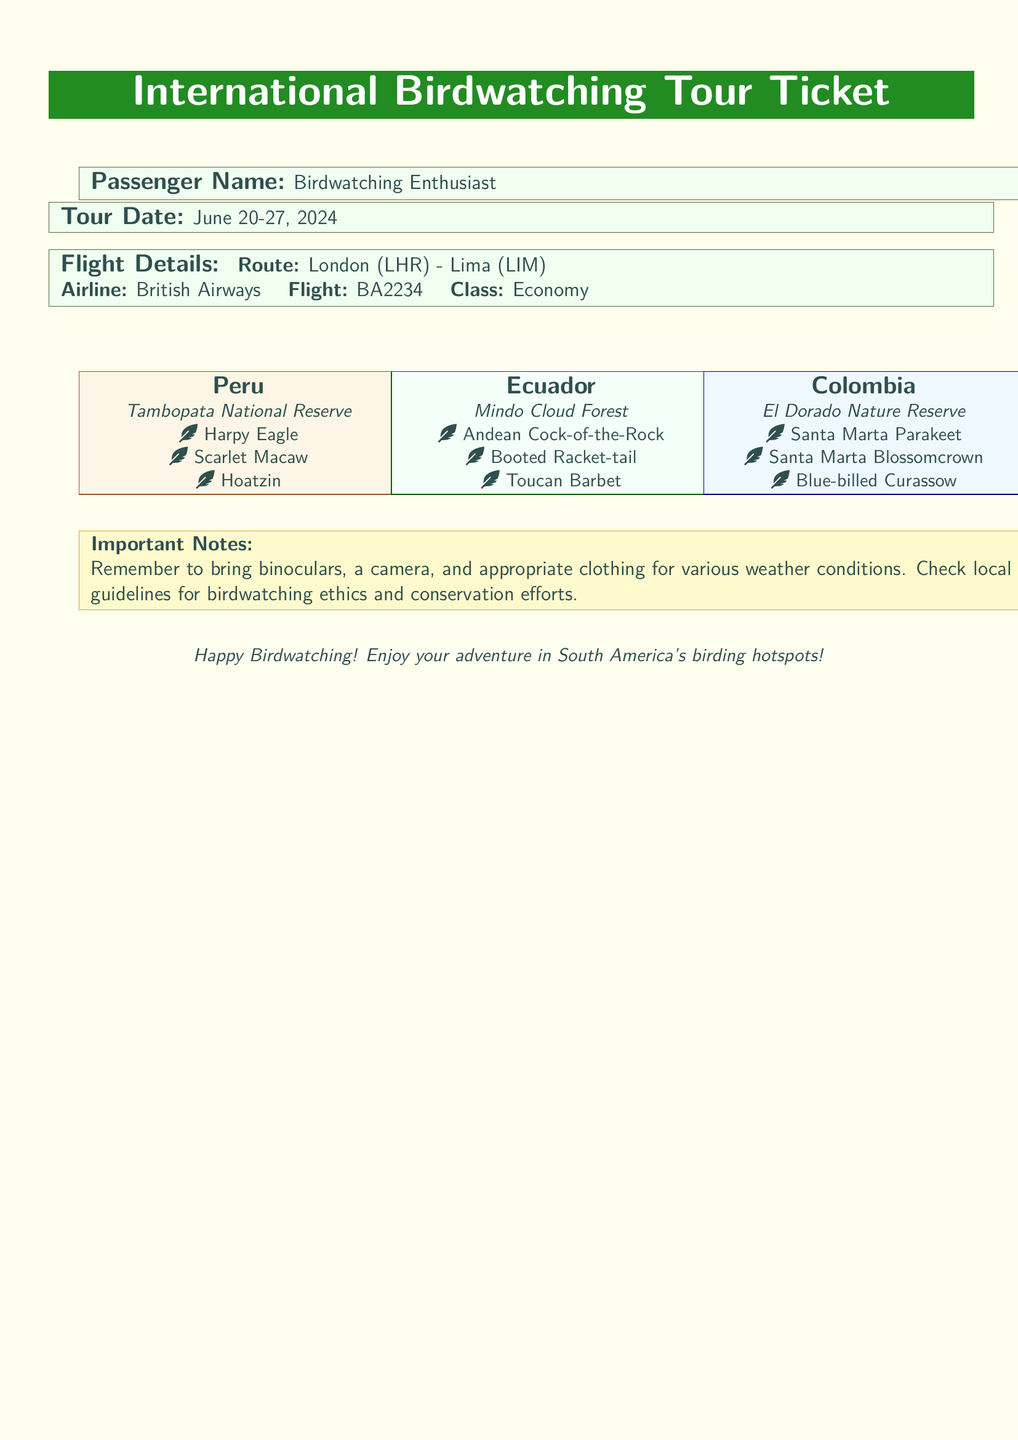What is the passenger name? The passenger name listed on the ticket is the first relevant detail presented in the document.
Answer: Birdwatching Enthusiast What are the tour dates? The tour dates are a crucial piece of information shown in a prominent section of the document.
Answer: June 20-27, 2024 What is the airline? The airline is mentioned in the flight details section, which provides specifics about the journey.
Answer: British Airways Which bird species can be observed in Peru? The document lists specific bird species that can be seen in each destination, focusing on Peru here.
Answer: Harpy Eagle, Scarlet Macaw, Hoatzin What is the location of the Mindo Cloud Forest? The location of the Mindo Cloud Forest is highlighted in the document, in combination with the expected bird species.
Answer: Ecuador What is one important note for travelers? Important notes for travelers are provided at the end of the document to ensure proper preparation for the tour.
Answer: Bring binoculars How many bird species are mentioned for Colombia? The document specifies the bird species expected to be observed in Colombia, which requires counting from the information given.
Answer: Three Which class is the ticket booked under? The class is a straightforward detail found in the flight details section of the document.
Answer: Economy What is the route for the flight? The route is clearly detailed within the flight information and is vital for understanding the trip.
Answer: London (LHR) - Lima (LIM) 